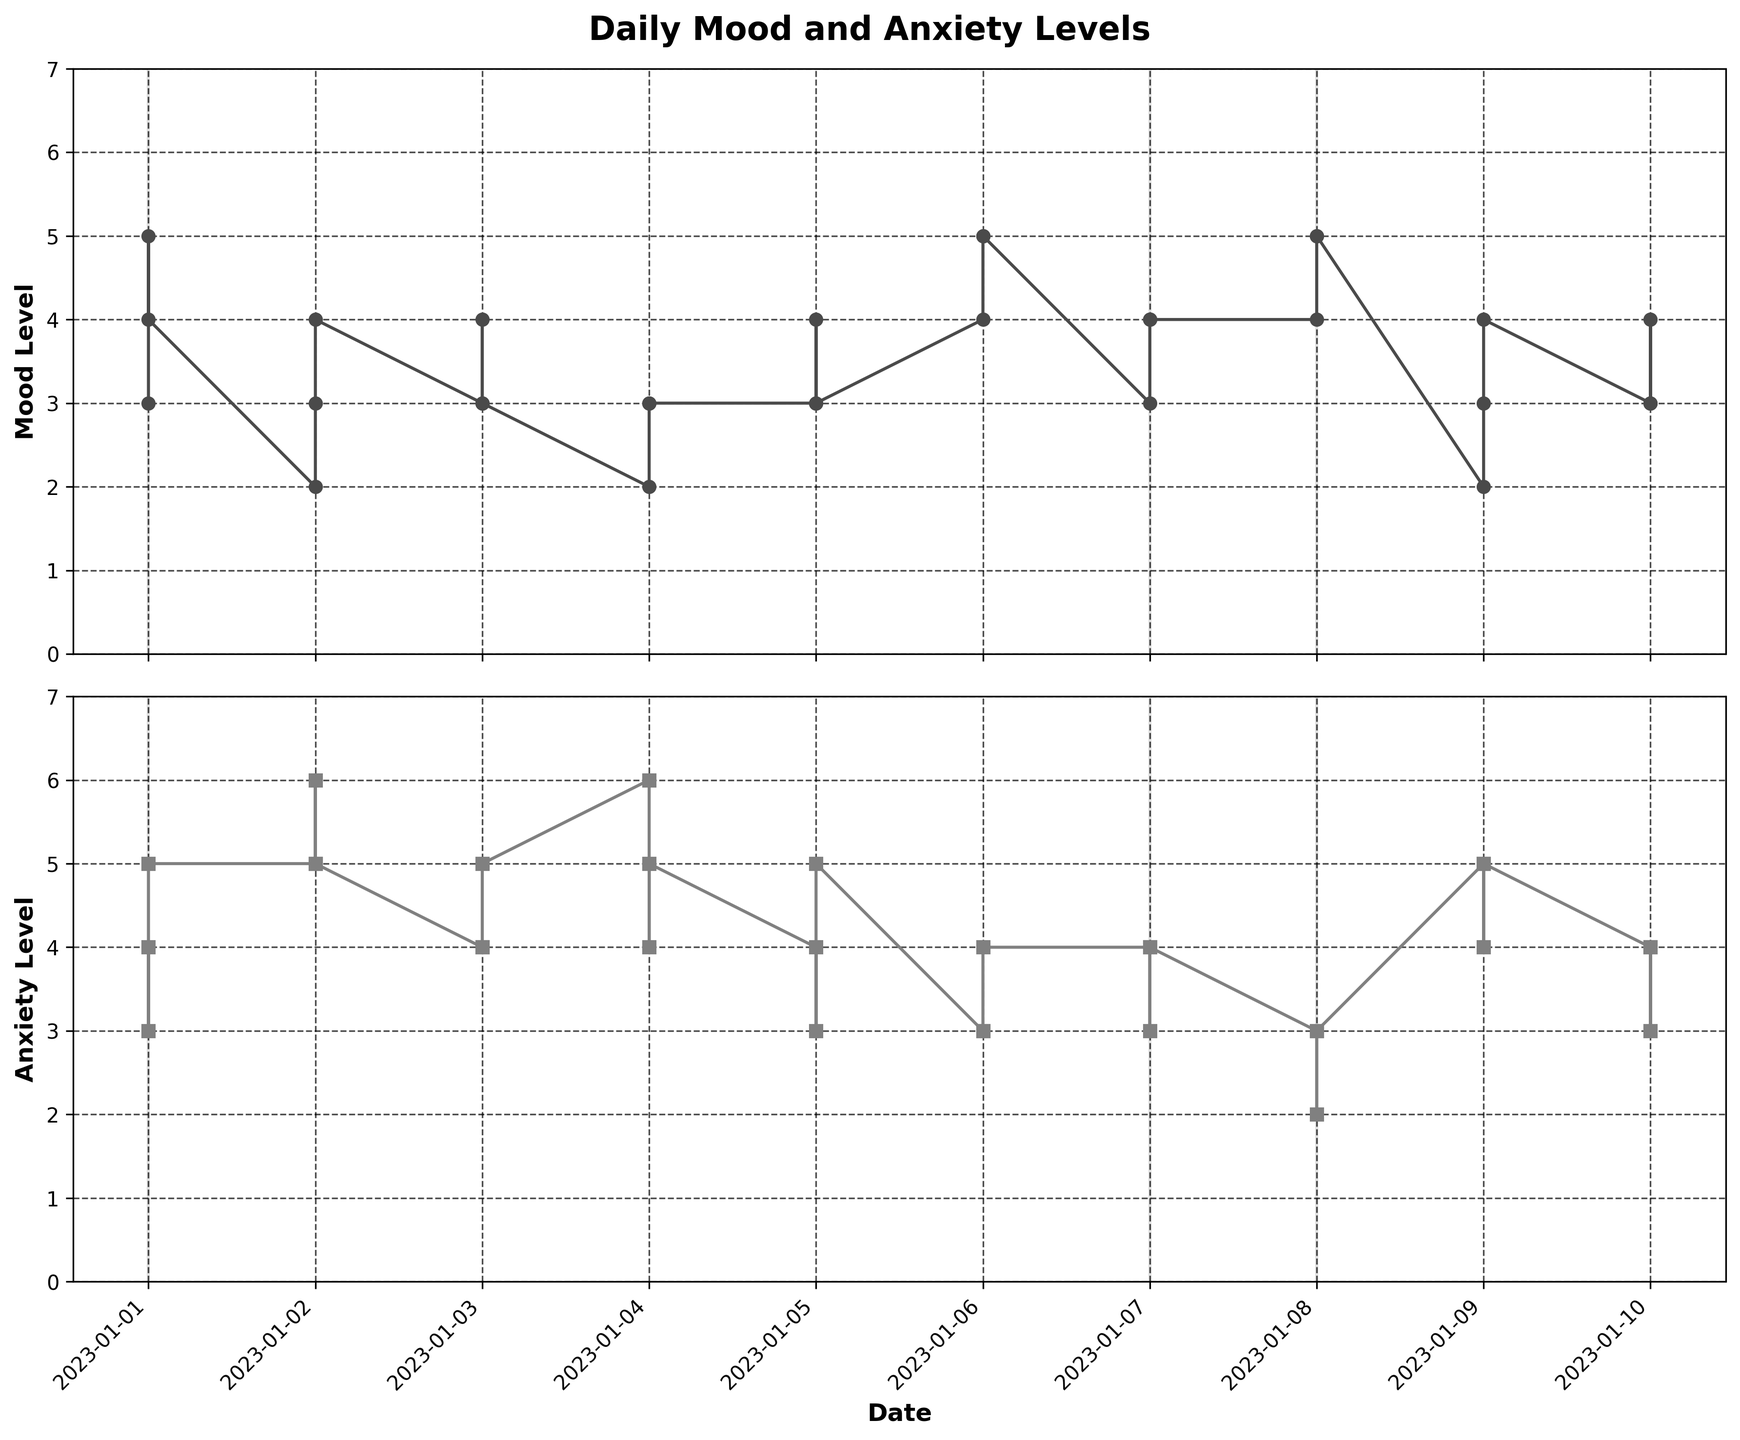What is the title of the figure? The title is located at the top center of the figure and reads "Daily Mood and Anxiety Levels".
Answer: Daily Mood and Anxiety Levels What are the y-axis labels for the two sub-plots? The y-axis for the first sub-plot (Mood Level) is labeled "Mood Level". The y-axis for the second sub-plot (Anxiety Level) is labeled "Anxiety Level".
Answer: Mood Level, Anxiety Level What range of values does the Mood Level cover on the y-axis? The y-axis for the Mood Level plot ranges from 0 to 7, as the minimum label is 0 and the maximum label is 7.
Answer: 0 to 7 How does the mood level change on Mondays at 08:00 over the displayed period? By examining the points on the plot corresponding to Mondays at 08:00, the Mood Level appears to remain consistent around 2 for multiple Mondays.
Answer: remains consistent around 2 Which day typically has higher anxiety levels: weekends or weekdays? By comparing the gridlines and markings on both sub-plots, weekdays generally show higher Anxiety Levels, especially in the morning.
Answer: weekdays On which day is the Mood Level highest? By scanning the highest points on the Mood Level sub-plot, the highest value of 5 can be observed on several days, including Fridays and Sundays.
Answer: Fridays and Sundays Compare the Mood and Anxiety Levels on January 2nd. On January 2nd, the Mood Level starts at 2 (08:00), rises to 3 (12:00), and ends at 4 (18:00). The Anxiety Level starts at 5 (08:00), rises to 6 (12:00), and drops to 5 (18:00).
Answer: Mood rises; Anxiety fluctuates What is the pattern of Anxiety Levels during the morning (08:00) across the displayed period? By looking at the 08:00 points in the Anxiety Level plot, the pattern shows variability but tends to be higher on weekdays compared to weekends.
Answer: higher on weekdays Do Mood Levels and Anxiety Levels seem to be inversely related? By comparing the plots, there is no consistent inverse relationship; both Mood and Anxiety Levels fluctuate independently.
Answer: No, they fluctuate independently 